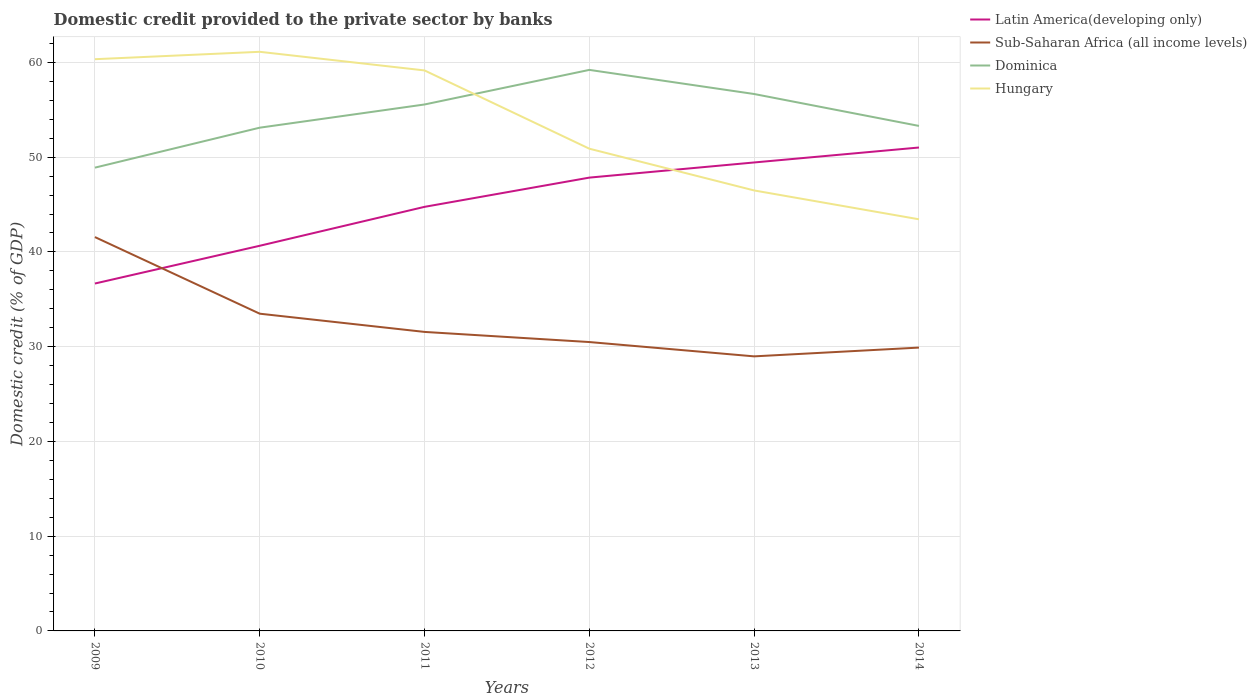Does the line corresponding to Hungary intersect with the line corresponding to Sub-Saharan Africa (all income levels)?
Your answer should be very brief. No. Across all years, what is the maximum domestic credit provided to the private sector by banks in Latin America(developing only)?
Your answer should be very brief. 36.67. In which year was the domestic credit provided to the private sector by banks in Dominica maximum?
Make the answer very short. 2009. What is the total domestic credit provided to the private sector by banks in Dominica in the graph?
Offer a terse response. 5.91. What is the difference between the highest and the second highest domestic credit provided to the private sector by banks in Dominica?
Offer a very short reply. 10.32. Is the domestic credit provided to the private sector by banks in Latin America(developing only) strictly greater than the domestic credit provided to the private sector by banks in Hungary over the years?
Offer a very short reply. No. How many lines are there?
Your answer should be very brief. 4. What is the difference between two consecutive major ticks on the Y-axis?
Provide a succinct answer. 10. Does the graph contain any zero values?
Offer a terse response. No. How many legend labels are there?
Provide a succinct answer. 4. What is the title of the graph?
Provide a short and direct response. Domestic credit provided to the private sector by banks. What is the label or title of the X-axis?
Provide a succinct answer. Years. What is the label or title of the Y-axis?
Ensure brevity in your answer.  Domestic credit (% of GDP). What is the Domestic credit (% of GDP) in Latin America(developing only) in 2009?
Your answer should be very brief. 36.67. What is the Domestic credit (% of GDP) of Sub-Saharan Africa (all income levels) in 2009?
Make the answer very short. 41.57. What is the Domestic credit (% of GDP) in Dominica in 2009?
Ensure brevity in your answer.  48.9. What is the Domestic credit (% of GDP) of Hungary in 2009?
Offer a terse response. 60.34. What is the Domestic credit (% of GDP) in Latin America(developing only) in 2010?
Make the answer very short. 40.65. What is the Domestic credit (% of GDP) in Sub-Saharan Africa (all income levels) in 2010?
Your response must be concise. 33.48. What is the Domestic credit (% of GDP) of Dominica in 2010?
Provide a succinct answer. 53.12. What is the Domestic credit (% of GDP) of Hungary in 2010?
Your response must be concise. 61.12. What is the Domestic credit (% of GDP) in Latin America(developing only) in 2011?
Provide a short and direct response. 44.76. What is the Domestic credit (% of GDP) in Sub-Saharan Africa (all income levels) in 2011?
Make the answer very short. 31.56. What is the Domestic credit (% of GDP) in Dominica in 2011?
Your answer should be very brief. 55.56. What is the Domestic credit (% of GDP) of Hungary in 2011?
Offer a very short reply. 59.16. What is the Domestic credit (% of GDP) of Latin America(developing only) in 2012?
Provide a succinct answer. 47.85. What is the Domestic credit (% of GDP) of Sub-Saharan Africa (all income levels) in 2012?
Provide a short and direct response. 30.49. What is the Domestic credit (% of GDP) of Dominica in 2012?
Provide a succinct answer. 59.21. What is the Domestic credit (% of GDP) of Hungary in 2012?
Make the answer very short. 50.9. What is the Domestic credit (% of GDP) in Latin America(developing only) in 2013?
Ensure brevity in your answer.  49.44. What is the Domestic credit (% of GDP) in Sub-Saharan Africa (all income levels) in 2013?
Ensure brevity in your answer.  28.98. What is the Domestic credit (% of GDP) of Dominica in 2013?
Give a very brief answer. 56.67. What is the Domestic credit (% of GDP) in Hungary in 2013?
Keep it short and to the point. 46.49. What is the Domestic credit (% of GDP) in Latin America(developing only) in 2014?
Provide a succinct answer. 51.02. What is the Domestic credit (% of GDP) in Sub-Saharan Africa (all income levels) in 2014?
Offer a terse response. 29.91. What is the Domestic credit (% of GDP) in Dominica in 2014?
Your answer should be very brief. 53.3. What is the Domestic credit (% of GDP) of Hungary in 2014?
Give a very brief answer. 43.45. Across all years, what is the maximum Domestic credit (% of GDP) of Latin America(developing only)?
Offer a terse response. 51.02. Across all years, what is the maximum Domestic credit (% of GDP) in Sub-Saharan Africa (all income levels)?
Offer a terse response. 41.57. Across all years, what is the maximum Domestic credit (% of GDP) of Dominica?
Your answer should be compact. 59.21. Across all years, what is the maximum Domestic credit (% of GDP) in Hungary?
Provide a succinct answer. 61.12. Across all years, what is the minimum Domestic credit (% of GDP) of Latin America(developing only)?
Make the answer very short. 36.67. Across all years, what is the minimum Domestic credit (% of GDP) in Sub-Saharan Africa (all income levels)?
Provide a succinct answer. 28.98. Across all years, what is the minimum Domestic credit (% of GDP) of Dominica?
Your answer should be compact. 48.9. Across all years, what is the minimum Domestic credit (% of GDP) in Hungary?
Give a very brief answer. 43.45. What is the total Domestic credit (% of GDP) in Latin America(developing only) in the graph?
Provide a succinct answer. 270.39. What is the total Domestic credit (% of GDP) of Sub-Saharan Africa (all income levels) in the graph?
Your answer should be compact. 195.98. What is the total Domestic credit (% of GDP) in Dominica in the graph?
Offer a terse response. 326.76. What is the total Domestic credit (% of GDP) of Hungary in the graph?
Keep it short and to the point. 321.46. What is the difference between the Domestic credit (% of GDP) in Latin America(developing only) in 2009 and that in 2010?
Ensure brevity in your answer.  -3.98. What is the difference between the Domestic credit (% of GDP) in Sub-Saharan Africa (all income levels) in 2009 and that in 2010?
Your answer should be compact. 8.09. What is the difference between the Domestic credit (% of GDP) in Dominica in 2009 and that in 2010?
Provide a short and direct response. -4.22. What is the difference between the Domestic credit (% of GDP) of Hungary in 2009 and that in 2010?
Your answer should be compact. -0.78. What is the difference between the Domestic credit (% of GDP) of Latin America(developing only) in 2009 and that in 2011?
Your answer should be compact. -8.09. What is the difference between the Domestic credit (% of GDP) in Sub-Saharan Africa (all income levels) in 2009 and that in 2011?
Offer a very short reply. 10.01. What is the difference between the Domestic credit (% of GDP) of Dominica in 2009 and that in 2011?
Offer a very short reply. -6.67. What is the difference between the Domestic credit (% of GDP) of Hungary in 2009 and that in 2011?
Provide a short and direct response. 1.19. What is the difference between the Domestic credit (% of GDP) of Latin America(developing only) in 2009 and that in 2012?
Your answer should be very brief. -11.18. What is the difference between the Domestic credit (% of GDP) of Sub-Saharan Africa (all income levels) in 2009 and that in 2012?
Your response must be concise. 11.08. What is the difference between the Domestic credit (% of GDP) in Dominica in 2009 and that in 2012?
Make the answer very short. -10.32. What is the difference between the Domestic credit (% of GDP) in Hungary in 2009 and that in 2012?
Offer a very short reply. 9.45. What is the difference between the Domestic credit (% of GDP) in Latin America(developing only) in 2009 and that in 2013?
Your answer should be very brief. -12.78. What is the difference between the Domestic credit (% of GDP) in Sub-Saharan Africa (all income levels) in 2009 and that in 2013?
Offer a terse response. 12.59. What is the difference between the Domestic credit (% of GDP) of Dominica in 2009 and that in 2013?
Give a very brief answer. -7.77. What is the difference between the Domestic credit (% of GDP) of Hungary in 2009 and that in 2013?
Provide a short and direct response. 13.85. What is the difference between the Domestic credit (% of GDP) in Latin America(developing only) in 2009 and that in 2014?
Provide a short and direct response. -14.36. What is the difference between the Domestic credit (% of GDP) in Sub-Saharan Africa (all income levels) in 2009 and that in 2014?
Offer a very short reply. 11.66. What is the difference between the Domestic credit (% of GDP) in Dominica in 2009 and that in 2014?
Your answer should be very brief. -4.4. What is the difference between the Domestic credit (% of GDP) in Hungary in 2009 and that in 2014?
Your response must be concise. 16.9. What is the difference between the Domestic credit (% of GDP) of Latin America(developing only) in 2010 and that in 2011?
Provide a succinct answer. -4.11. What is the difference between the Domestic credit (% of GDP) in Sub-Saharan Africa (all income levels) in 2010 and that in 2011?
Keep it short and to the point. 1.92. What is the difference between the Domestic credit (% of GDP) in Dominica in 2010 and that in 2011?
Make the answer very short. -2.45. What is the difference between the Domestic credit (% of GDP) in Hungary in 2010 and that in 2011?
Keep it short and to the point. 1.97. What is the difference between the Domestic credit (% of GDP) in Latin America(developing only) in 2010 and that in 2012?
Provide a succinct answer. -7.19. What is the difference between the Domestic credit (% of GDP) in Sub-Saharan Africa (all income levels) in 2010 and that in 2012?
Your response must be concise. 2.99. What is the difference between the Domestic credit (% of GDP) in Dominica in 2010 and that in 2012?
Your answer should be compact. -6.1. What is the difference between the Domestic credit (% of GDP) of Hungary in 2010 and that in 2012?
Provide a short and direct response. 10.23. What is the difference between the Domestic credit (% of GDP) of Latin America(developing only) in 2010 and that in 2013?
Your answer should be very brief. -8.79. What is the difference between the Domestic credit (% of GDP) in Sub-Saharan Africa (all income levels) in 2010 and that in 2013?
Offer a very short reply. 4.5. What is the difference between the Domestic credit (% of GDP) in Dominica in 2010 and that in 2013?
Provide a succinct answer. -3.55. What is the difference between the Domestic credit (% of GDP) of Hungary in 2010 and that in 2013?
Provide a succinct answer. 14.63. What is the difference between the Domestic credit (% of GDP) of Latin America(developing only) in 2010 and that in 2014?
Your response must be concise. -10.37. What is the difference between the Domestic credit (% of GDP) in Sub-Saharan Africa (all income levels) in 2010 and that in 2014?
Make the answer very short. 3.58. What is the difference between the Domestic credit (% of GDP) of Dominica in 2010 and that in 2014?
Give a very brief answer. -0.19. What is the difference between the Domestic credit (% of GDP) in Hungary in 2010 and that in 2014?
Your response must be concise. 17.68. What is the difference between the Domestic credit (% of GDP) in Latin America(developing only) in 2011 and that in 2012?
Keep it short and to the point. -3.09. What is the difference between the Domestic credit (% of GDP) in Sub-Saharan Africa (all income levels) in 2011 and that in 2012?
Make the answer very short. 1.07. What is the difference between the Domestic credit (% of GDP) in Dominica in 2011 and that in 2012?
Offer a terse response. -3.65. What is the difference between the Domestic credit (% of GDP) of Hungary in 2011 and that in 2012?
Keep it short and to the point. 8.26. What is the difference between the Domestic credit (% of GDP) of Latin America(developing only) in 2011 and that in 2013?
Ensure brevity in your answer.  -4.68. What is the difference between the Domestic credit (% of GDP) in Sub-Saharan Africa (all income levels) in 2011 and that in 2013?
Provide a succinct answer. 2.58. What is the difference between the Domestic credit (% of GDP) in Dominica in 2011 and that in 2013?
Give a very brief answer. -1.1. What is the difference between the Domestic credit (% of GDP) in Hungary in 2011 and that in 2013?
Offer a terse response. 12.67. What is the difference between the Domestic credit (% of GDP) of Latin America(developing only) in 2011 and that in 2014?
Your response must be concise. -6.26. What is the difference between the Domestic credit (% of GDP) in Sub-Saharan Africa (all income levels) in 2011 and that in 2014?
Your answer should be very brief. 1.65. What is the difference between the Domestic credit (% of GDP) of Dominica in 2011 and that in 2014?
Offer a terse response. 2.26. What is the difference between the Domestic credit (% of GDP) in Hungary in 2011 and that in 2014?
Your answer should be compact. 15.71. What is the difference between the Domestic credit (% of GDP) of Latin America(developing only) in 2012 and that in 2013?
Provide a succinct answer. -1.6. What is the difference between the Domestic credit (% of GDP) in Sub-Saharan Africa (all income levels) in 2012 and that in 2013?
Your response must be concise. 1.51. What is the difference between the Domestic credit (% of GDP) in Dominica in 2012 and that in 2013?
Provide a short and direct response. 2.55. What is the difference between the Domestic credit (% of GDP) of Hungary in 2012 and that in 2013?
Offer a very short reply. 4.41. What is the difference between the Domestic credit (% of GDP) in Latin America(developing only) in 2012 and that in 2014?
Ensure brevity in your answer.  -3.18. What is the difference between the Domestic credit (% of GDP) in Sub-Saharan Africa (all income levels) in 2012 and that in 2014?
Give a very brief answer. 0.58. What is the difference between the Domestic credit (% of GDP) of Dominica in 2012 and that in 2014?
Ensure brevity in your answer.  5.91. What is the difference between the Domestic credit (% of GDP) of Hungary in 2012 and that in 2014?
Provide a succinct answer. 7.45. What is the difference between the Domestic credit (% of GDP) in Latin America(developing only) in 2013 and that in 2014?
Provide a short and direct response. -1.58. What is the difference between the Domestic credit (% of GDP) of Sub-Saharan Africa (all income levels) in 2013 and that in 2014?
Ensure brevity in your answer.  -0.93. What is the difference between the Domestic credit (% of GDP) in Dominica in 2013 and that in 2014?
Your response must be concise. 3.37. What is the difference between the Domestic credit (% of GDP) in Hungary in 2013 and that in 2014?
Provide a succinct answer. 3.04. What is the difference between the Domestic credit (% of GDP) in Latin America(developing only) in 2009 and the Domestic credit (% of GDP) in Sub-Saharan Africa (all income levels) in 2010?
Provide a succinct answer. 3.18. What is the difference between the Domestic credit (% of GDP) in Latin America(developing only) in 2009 and the Domestic credit (% of GDP) in Dominica in 2010?
Your response must be concise. -16.45. What is the difference between the Domestic credit (% of GDP) in Latin America(developing only) in 2009 and the Domestic credit (% of GDP) in Hungary in 2010?
Offer a terse response. -24.46. What is the difference between the Domestic credit (% of GDP) of Sub-Saharan Africa (all income levels) in 2009 and the Domestic credit (% of GDP) of Dominica in 2010?
Keep it short and to the point. -11.55. What is the difference between the Domestic credit (% of GDP) of Sub-Saharan Africa (all income levels) in 2009 and the Domestic credit (% of GDP) of Hungary in 2010?
Keep it short and to the point. -19.56. What is the difference between the Domestic credit (% of GDP) in Dominica in 2009 and the Domestic credit (% of GDP) in Hungary in 2010?
Make the answer very short. -12.23. What is the difference between the Domestic credit (% of GDP) of Latin America(developing only) in 2009 and the Domestic credit (% of GDP) of Sub-Saharan Africa (all income levels) in 2011?
Your answer should be compact. 5.11. What is the difference between the Domestic credit (% of GDP) in Latin America(developing only) in 2009 and the Domestic credit (% of GDP) in Dominica in 2011?
Make the answer very short. -18.9. What is the difference between the Domestic credit (% of GDP) in Latin America(developing only) in 2009 and the Domestic credit (% of GDP) in Hungary in 2011?
Your answer should be very brief. -22.49. What is the difference between the Domestic credit (% of GDP) of Sub-Saharan Africa (all income levels) in 2009 and the Domestic credit (% of GDP) of Dominica in 2011?
Your answer should be very brief. -14. What is the difference between the Domestic credit (% of GDP) in Sub-Saharan Africa (all income levels) in 2009 and the Domestic credit (% of GDP) in Hungary in 2011?
Provide a succinct answer. -17.59. What is the difference between the Domestic credit (% of GDP) in Dominica in 2009 and the Domestic credit (% of GDP) in Hungary in 2011?
Your answer should be very brief. -10.26. What is the difference between the Domestic credit (% of GDP) of Latin America(developing only) in 2009 and the Domestic credit (% of GDP) of Sub-Saharan Africa (all income levels) in 2012?
Provide a succinct answer. 6.18. What is the difference between the Domestic credit (% of GDP) in Latin America(developing only) in 2009 and the Domestic credit (% of GDP) in Dominica in 2012?
Ensure brevity in your answer.  -22.55. What is the difference between the Domestic credit (% of GDP) of Latin America(developing only) in 2009 and the Domestic credit (% of GDP) of Hungary in 2012?
Give a very brief answer. -14.23. What is the difference between the Domestic credit (% of GDP) in Sub-Saharan Africa (all income levels) in 2009 and the Domestic credit (% of GDP) in Dominica in 2012?
Your answer should be compact. -17.65. What is the difference between the Domestic credit (% of GDP) in Sub-Saharan Africa (all income levels) in 2009 and the Domestic credit (% of GDP) in Hungary in 2012?
Your response must be concise. -9.33. What is the difference between the Domestic credit (% of GDP) of Dominica in 2009 and the Domestic credit (% of GDP) of Hungary in 2012?
Your response must be concise. -2. What is the difference between the Domestic credit (% of GDP) of Latin America(developing only) in 2009 and the Domestic credit (% of GDP) of Sub-Saharan Africa (all income levels) in 2013?
Provide a succinct answer. 7.69. What is the difference between the Domestic credit (% of GDP) in Latin America(developing only) in 2009 and the Domestic credit (% of GDP) in Dominica in 2013?
Give a very brief answer. -20. What is the difference between the Domestic credit (% of GDP) of Latin America(developing only) in 2009 and the Domestic credit (% of GDP) of Hungary in 2013?
Offer a very short reply. -9.82. What is the difference between the Domestic credit (% of GDP) of Sub-Saharan Africa (all income levels) in 2009 and the Domestic credit (% of GDP) of Dominica in 2013?
Keep it short and to the point. -15.1. What is the difference between the Domestic credit (% of GDP) in Sub-Saharan Africa (all income levels) in 2009 and the Domestic credit (% of GDP) in Hungary in 2013?
Provide a short and direct response. -4.92. What is the difference between the Domestic credit (% of GDP) in Dominica in 2009 and the Domestic credit (% of GDP) in Hungary in 2013?
Your answer should be very brief. 2.41. What is the difference between the Domestic credit (% of GDP) of Latin America(developing only) in 2009 and the Domestic credit (% of GDP) of Sub-Saharan Africa (all income levels) in 2014?
Your answer should be compact. 6.76. What is the difference between the Domestic credit (% of GDP) in Latin America(developing only) in 2009 and the Domestic credit (% of GDP) in Dominica in 2014?
Your answer should be compact. -16.64. What is the difference between the Domestic credit (% of GDP) of Latin America(developing only) in 2009 and the Domestic credit (% of GDP) of Hungary in 2014?
Keep it short and to the point. -6.78. What is the difference between the Domestic credit (% of GDP) of Sub-Saharan Africa (all income levels) in 2009 and the Domestic credit (% of GDP) of Dominica in 2014?
Your answer should be very brief. -11.73. What is the difference between the Domestic credit (% of GDP) in Sub-Saharan Africa (all income levels) in 2009 and the Domestic credit (% of GDP) in Hungary in 2014?
Offer a very short reply. -1.88. What is the difference between the Domestic credit (% of GDP) of Dominica in 2009 and the Domestic credit (% of GDP) of Hungary in 2014?
Keep it short and to the point. 5.45. What is the difference between the Domestic credit (% of GDP) in Latin America(developing only) in 2010 and the Domestic credit (% of GDP) in Sub-Saharan Africa (all income levels) in 2011?
Your answer should be compact. 9.09. What is the difference between the Domestic credit (% of GDP) in Latin America(developing only) in 2010 and the Domestic credit (% of GDP) in Dominica in 2011?
Your answer should be very brief. -14.91. What is the difference between the Domestic credit (% of GDP) of Latin America(developing only) in 2010 and the Domestic credit (% of GDP) of Hungary in 2011?
Keep it short and to the point. -18.51. What is the difference between the Domestic credit (% of GDP) in Sub-Saharan Africa (all income levels) in 2010 and the Domestic credit (% of GDP) in Dominica in 2011?
Ensure brevity in your answer.  -22.08. What is the difference between the Domestic credit (% of GDP) in Sub-Saharan Africa (all income levels) in 2010 and the Domestic credit (% of GDP) in Hungary in 2011?
Offer a terse response. -25.68. What is the difference between the Domestic credit (% of GDP) of Dominica in 2010 and the Domestic credit (% of GDP) of Hungary in 2011?
Give a very brief answer. -6.04. What is the difference between the Domestic credit (% of GDP) in Latin America(developing only) in 2010 and the Domestic credit (% of GDP) in Sub-Saharan Africa (all income levels) in 2012?
Offer a very short reply. 10.16. What is the difference between the Domestic credit (% of GDP) in Latin America(developing only) in 2010 and the Domestic credit (% of GDP) in Dominica in 2012?
Your response must be concise. -18.56. What is the difference between the Domestic credit (% of GDP) of Latin America(developing only) in 2010 and the Domestic credit (% of GDP) of Hungary in 2012?
Your answer should be very brief. -10.25. What is the difference between the Domestic credit (% of GDP) in Sub-Saharan Africa (all income levels) in 2010 and the Domestic credit (% of GDP) in Dominica in 2012?
Offer a terse response. -25.73. What is the difference between the Domestic credit (% of GDP) in Sub-Saharan Africa (all income levels) in 2010 and the Domestic credit (% of GDP) in Hungary in 2012?
Your answer should be very brief. -17.41. What is the difference between the Domestic credit (% of GDP) of Dominica in 2010 and the Domestic credit (% of GDP) of Hungary in 2012?
Your response must be concise. 2.22. What is the difference between the Domestic credit (% of GDP) in Latin America(developing only) in 2010 and the Domestic credit (% of GDP) in Sub-Saharan Africa (all income levels) in 2013?
Provide a short and direct response. 11.67. What is the difference between the Domestic credit (% of GDP) in Latin America(developing only) in 2010 and the Domestic credit (% of GDP) in Dominica in 2013?
Give a very brief answer. -16.02. What is the difference between the Domestic credit (% of GDP) in Latin America(developing only) in 2010 and the Domestic credit (% of GDP) in Hungary in 2013?
Your response must be concise. -5.84. What is the difference between the Domestic credit (% of GDP) of Sub-Saharan Africa (all income levels) in 2010 and the Domestic credit (% of GDP) of Dominica in 2013?
Give a very brief answer. -23.19. What is the difference between the Domestic credit (% of GDP) of Sub-Saharan Africa (all income levels) in 2010 and the Domestic credit (% of GDP) of Hungary in 2013?
Make the answer very short. -13.01. What is the difference between the Domestic credit (% of GDP) in Dominica in 2010 and the Domestic credit (% of GDP) in Hungary in 2013?
Give a very brief answer. 6.63. What is the difference between the Domestic credit (% of GDP) of Latin America(developing only) in 2010 and the Domestic credit (% of GDP) of Sub-Saharan Africa (all income levels) in 2014?
Ensure brevity in your answer.  10.75. What is the difference between the Domestic credit (% of GDP) in Latin America(developing only) in 2010 and the Domestic credit (% of GDP) in Dominica in 2014?
Ensure brevity in your answer.  -12.65. What is the difference between the Domestic credit (% of GDP) of Latin America(developing only) in 2010 and the Domestic credit (% of GDP) of Hungary in 2014?
Your response must be concise. -2.8. What is the difference between the Domestic credit (% of GDP) of Sub-Saharan Africa (all income levels) in 2010 and the Domestic credit (% of GDP) of Dominica in 2014?
Ensure brevity in your answer.  -19.82. What is the difference between the Domestic credit (% of GDP) of Sub-Saharan Africa (all income levels) in 2010 and the Domestic credit (% of GDP) of Hungary in 2014?
Provide a short and direct response. -9.96. What is the difference between the Domestic credit (% of GDP) in Dominica in 2010 and the Domestic credit (% of GDP) in Hungary in 2014?
Provide a succinct answer. 9.67. What is the difference between the Domestic credit (% of GDP) in Latin America(developing only) in 2011 and the Domestic credit (% of GDP) in Sub-Saharan Africa (all income levels) in 2012?
Make the answer very short. 14.27. What is the difference between the Domestic credit (% of GDP) of Latin America(developing only) in 2011 and the Domestic credit (% of GDP) of Dominica in 2012?
Provide a short and direct response. -14.46. What is the difference between the Domestic credit (% of GDP) of Latin America(developing only) in 2011 and the Domestic credit (% of GDP) of Hungary in 2012?
Offer a very short reply. -6.14. What is the difference between the Domestic credit (% of GDP) in Sub-Saharan Africa (all income levels) in 2011 and the Domestic credit (% of GDP) in Dominica in 2012?
Keep it short and to the point. -27.66. What is the difference between the Domestic credit (% of GDP) of Sub-Saharan Africa (all income levels) in 2011 and the Domestic credit (% of GDP) of Hungary in 2012?
Keep it short and to the point. -19.34. What is the difference between the Domestic credit (% of GDP) of Dominica in 2011 and the Domestic credit (% of GDP) of Hungary in 2012?
Ensure brevity in your answer.  4.67. What is the difference between the Domestic credit (% of GDP) in Latin America(developing only) in 2011 and the Domestic credit (% of GDP) in Sub-Saharan Africa (all income levels) in 2013?
Provide a succinct answer. 15.78. What is the difference between the Domestic credit (% of GDP) in Latin America(developing only) in 2011 and the Domestic credit (% of GDP) in Dominica in 2013?
Keep it short and to the point. -11.91. What is the difference between the Domestic credit (% of GDP) in Latin America(developing only) in 2011 and the Domestic credit (% of GDP) in Hungary in 2013?
Give a very brief answer. -1.73. What is the difference between the Domestic credit (% of GDP) of Sub-Saharan Africa (all income levels) in 2011 and the Domestic credit (% of GDP) of Dominica in 2013?
Your answer should be compact. -25.11. What is the difference between the Domestic credit (% of GDP) in Sub-Saharan Africa (all income levels) in 2011 and the Domestic credit (% of GDP) in Hungary in 2013?
Offer a very short reply. -14.93. What is the difference between the Domestic credit (% of GDP) of Dominica in 2011 and the Domestic credit (% of GDP) of Hungary in 2013?
Your response must be concise. 9.07. What is the difference between the Domestic credit (% of GDP) in Latin America(developing only) in 2011 and the Domestic credit (% of GDP) in Sub-Saharan Africa (all income levels) in 2014?
Your answer should be compact. 14.85. What is the difference between the Domestic credit (% of GDP) of Latin America(developing only) in 2011 and the Domestic credit (% of GDP) of Dominica in 2014?
Offer a terse response. -8.54. What is the difference between the Domestic credit (% of GDP) of Latin America(developing only) in 2011 and the Domestic credit (% of GDP) of Hungary in 2014?
Provide a short and direct response. 1.31. What is the difference between the Domestic credit (% of GDP) in Sub-Saharan Africa (all income levels) in 2011 and the Domestic credit (% of GDP) in Dominica in 2014?
Your answer should be compact. -21.74. What is the difference between the Domestic credit (% of GDP) in Sub-Saharan Africa (all income levels) in 2011 and the Domestic credit (% of GDP) in Hungary in 2014?
Give a very brief answer. -11.89. What is the difference between the Domestic credit (% of GDP) in Dominica in 2011 and the Domestic credit (% of GDP) in Hungary in 2014?
Your answer should be compact. 12.12. What is the difference between the Domestic credit (% of GDP) of Latin America(developing only) in 2012 and the Domestic credit (% of GDP) of Sub-Saharan Africa (all income levels) in 2013?
Give a very brief answer. 18.87. What is the difference between the Domestic credit (% of GDP) of Latin America(developing only) in 2012 and the Domestic credit (% of GDP) of Dominica in 2013?
Keep it short and to the point. -8.82. What is the difference between the Domestic credit (% of GDP) in Latin America(developing only) in 2012 and the Domestic credit (% of GDP) in Hungary in 2013?
Ensure brevity in your answer.  1.35. What is the difference between the Domestic credit (% of GDP) in Sub-Saharan Africa (all income levels) in 2012 and the Domestic credit (% of GDP) in Dominica in 2013?
Your answer should be very brief. -26.18. What is the difference between the Domestic credit (% of GDP) in Sub-Saharan Africa (all income levels) in 2012 and the Domestic credit (% of GDP) in Hungary in 2013?
Your answer should be very brief. -16. What is the difference between the Domestic credit (% of GDP) of Dominica in 2012 and the Domestic credit (% of GDP) of Hungary in 2013?
Ensure brevity in your answer.  12.72. What is the difference between the Domestic credit (% of GDP) of Latin America(developing only) in 2012 and the Domestic credit (% of GDP) of Sub-Saharan Africa (all income levels) in 2014?
Give a very brief answer. 17.94. What is the difference between the Domestic credit (% of GDP) in Latin America(developing only) in 2012 and the Domestic credit (% of GDP) in Dominica in 2014?
Offer a terse response. -5.46. What is the difference between the Domestic credit (% of GDP) of Latin America(developing only) in 2012 and the Domestic credit (% of GDP) of Hungary in 2014?
Ensure brevity in your answer.  4.4. What is the difference between the Domestic credit (% of GDP) in Sub-Saharan Africa (all income levels) in 2012 and the Domestic credit (% of GDP) in Dominica in 2014?
Make the answer very short. -22.81. What is the difference between the Domestic credit (% of GDP) of Sub-Saharan Africa (all income levels) in 2012 and the Domestic credit (% of GDP) of Hungary in 2014?
Offer a very short reply. -12.96. What is the difference between the Domestic credit (% of GDP) in Dominica in 2012 and the Domestic credit (% of GDP) in Hungary in 2014?
Your response must be concise. 15.77. What is the difference between the Domestic credit (% of GDP) of Latin America(developing only) in 2013 and the Domestic credit (% of GDP) of Sub-Saharan Africa (all income levels) in 2014?
Your response must be concise. 19.54. What is the difference between the Domestic credit (% of GDP) of Latin America(developing only) in 2013 and the Domestic credit (% of GDP) of Dominica in 2014?
Offer a very short reply. -3.86. What is the difference between the Domestic credit (% of GDP) in Latin America(developing only) in 2013 and the Domestic credit (% of GDP) in Hungary in 2014?
Keep it short and to the point. 6. What is the difference between the Domestic credit (% of GDP) of Sub-Saharan Africa (all income levels) in 2013 and the Domestic credit (% of GDP) of Dominica in 2014?
Ensure brevity in your answer.  -24.32. What is the difference between the Domestic credit (% of GDP) of Sub-Saharan Africa (all income levels) in 2013 and the Domestic credit (% of GDP) of Hungary in 2014?
Provide a short and direct response. -14.47. What is the difference between the Domestic credit (% of GDP) of Dominica in 2013 and the Domestic credit (% of GDP) of Hungary in 2014?
Offer a terse response. 13.22. What is the average Domestic credit (% of GDP) of Latin America(developing only) per year?
Your answer should be compact. 45.06. What is the average Domestic credit (% of GDP) in Sub-Saharan Africa (all income levels) per year?
Keep it short and to the point. 32.66. What is the average Domestic credit (% of GDP) in Dominica per year?
Keep it short and to the point. 54.46. What is the average Domestic credit (% of GDP) of Hungary per year?
Ensure brevity in your answer.  53.58. In the year 2009, what is the difference between the Domestic credit (% of GDP) of Latin America(developing only) and Domestic credit (% of GDP) of Sub-Saharan Africa (all income levels)?
Your answer should be compact. -4.9. In the year 2009, what is the difference between the Domestic credit (% of GDP) of Latin America(developing only) and Domestic credit (% of GDP) of Dominica?
Provide a succinct answer. -12.23. In the year 2009, what is the difference between the Domestic credit (% of GDP) of Latin America(developing only) and Domestic credit (% of GDP) of Hungary?
Keep it short and to the point. -23.68. In the year 2009, what is the difference between the Domestic credit (% of GDP) in Sub-Saharan Africa (all income levels) and Domestic credit (% of GDP) in Dominica?
Make the answer very short. -7.33. In the year 2009, what is the difference between the Domestic credit (% of GDP) of Sub-Saharan Africa (all income levels) and Domestic credit (% of GDP) of Hungary?
Make the answer very short. -18.78. In the year 2009, what is the difference between the Domestic credit (% of GDP) in Dominica and Domestic credit (% of GDP) in Hungary?
Your answer should be very brief. -11.45. In the year 2010, what is the difference between the Domestic credit (% of GDP) in Latin America(developing only) and Domestic credit (% of GDP) in Sub-Saharan Africa (all income levels)?
Ensure brevity in your answer.  7.17. In the year 2010, what is the difference between the Domestic credit (% of GDP) in Latin America(developing only) and Domestic credit (% of GDP) in Dominica?
Keep it short and to the point. -12.47. In the year 2010, what is the difference between the Domestic credit (% of GDP) of Latin America(developing only) and Domestic credit (% of GDP) of Hungary?
Your answer should be very brief. -20.47. In the year 2010, what is the difference between the Domestic credit (% of GDP) of Sub-Saharan Africa (all income levels) and Domestic credit (% of GDP) of Dominica?
Provide a succinct answer. -19.63. In the year 2010, what is the difference between the Domestic credit (% of GDP) in Sub-Saharan Africa (all income levels) and Domestic credit (% of GDP) in Hungary?
Make the answer very short. -27.64. In the year 2010, what is the difference between the Domestic credit (% of GDP) in Dominica and Domestic credit (% of GDP) in Hungary?
Your answer should be compact. -8.01. In the year 2011, what is the difference between the Domestic credit (% of GDP) of Latin America(developing only) and Domestic credit (% of GDP) of Sub-Saharan Africa (all income levels)?
Give a very brief answer. 13.2. In the year 2011, what is the difference between the Domestic credit (% of GDP) in Latin America(developing only) and Domestic credit (% of GDP) in Dominica?
Ensure brevity in your answer.  -10.8. In the year 2011, what is the difference between the Domestic credit (% of GDP) in Latin America(developing only) and Domestic credit (% of GDP) in Hungary?
Offer a very short reply. -14.4. In the year 2011, what is the difference between the Domestic credit (% of GDP) of Sub-Saharan Africa (all income levels) and Domestic credit (% of GDP) of Dominica?
Provide a succinct answer. -24.01. In the year 2011, what is the difference between the Domestic credit (% of GDP) in Sub-Saharan Africa (all income levels) and Domestic credit (% of GDP) in Hungary?
Your answer should be very brief. -27.6. In the year 2011, what is the difference between the Domestic credit (% of GDP) in Dominica and Domestic credit (% of GDP) in Hungary?
Your answer should be compact. -3.59. In the year 2012, what is the difference between the Domestic credit (% of GDP) in Latin America(developing only) and Domestic credit (% of GDP) in Sub-Saharan Africa (all income levels)?
Your answer should be very brief. 17.36. In the year 2012, what is the difference between the Domestic credit (% of GDP) of Latin America(developing only) and Domestic credit (% of GDP) of Dominica?
Your answer should be very brief. -11.37. In the year 2012, what is the difference between the Domestic credit (% of GDP) of Latin America(developing only) and Domestic credit (% of GDP) of Hungary?
Ensure brevity in your answer.  -3.05. In the year 2012, what is the difference between the Domestic credit (% of GDP) in Sub-Saharan Africa (all income levels) and Domestic credit (% of GDP) in Dominica?
Ensure brevity in your answer.  -28.73. In the year 2012, what is the difference between the Domestic credit (% of GDP) of Sub-Saharan Africa (all income levels) and Domestic credit (% of GDP) of Hungary?
Your answer should be very brief. -20.41. In the year 2012, what is the difference between the Domestic credit (% of GDP) of Dominica and Domestic credit (% of GDP) of Hungary?
Keep it short and to the point. 8.32. In the year 2013, what is the difference between the Domestic credit (% of GDP) in Latin America(developing only) and Domestic credit (% of GDP) in Sub-Saharan Africa (all income levels)?
Offer a terse response. 20.47. In the year 2013, what is the difference between the Domestic credit (% of GDP) in Latin America(developing only) and Domestic credit (% of GDP) in Dominica?
Your response must be concise. -7.22. In the year 2013, what is the difference between the Domestic credit (% of GDP) of Latin America(developing only) and Domestic credit (% of GDP) of Hungary?
Offer a terse response. 2.95. In the year 2013, what is the difference between the Domestic credit (% of GDP) of Sub-Saharan Africa (all income levels) and Domestic credit (% of GDP) of Dominica?
Your answer should be compact. -27.69. In the year 2013, what is the difference between the Domestic credit (% of GDP) in Sub-Saharan Africa (all income levels) and Domestic credit (% of GDP) in Hungary?
Make the answer very short. -17.51. In the year 2013, what is the difference between the Domestic credit (% of GDP) of Dominica and Domestic credit (% of GDP) of Hungary?
Ensure brevity in your answer.  10.18. In the year 2014, what is the difference between the Domestic credit (% of GDP) in Latin America(developing only) and Domestic credit (% of GDP) in Sub-Saharan Africa (all income levels)?
Keep it short and to the point. 21.12. In the year 2014, what is the difference between the Domestic credit (% of GDP) of Latin America(developing only) and Domestic credit (% of GDP) of Dominica?
Your answer should be very brief. -2.28. In the year 2014, what is the difference between the Domestic credit (% of GDP) in Latin America(developing only) and Domestic credit (% of GDP) in Hungary?
Offer a very short reply. 7.58. In the year 2014, what is the difference between the Domestic credit (% of GDP) of Sub-Saharan Africa (all income levels) and Domestic credit (% of GDP) of Dominica?
Provide a succinct answer. -23.4. In the year 2014, what is the difference between the Domestic credit (% of GDP) of Sub-Saharan Africa (all income levels) and Domestic credit (% of GDP) of Hungary?
Offer a terse response. -13.54. In the year 2014, what is the difference between the Domestic credit (% of GDP) in Dominica and Domestic credit (% of GDP) in Hungary?
Your response must be concise. 9.86. What is the ratio of the Domestic credit (% of GDP) of Latin America(developing only) in 2009 to that in 2010?
Your response must be concise. 0.9. What is the ratio of the Domestic credit (% of GDP) in Sub-Saharan Africa (all income levels) in 2009 to that in 2010?
Keep it short and to the point. 1.24. What is the ratio of the Domestic credit (% of GDP) of Dominica in 2009 to that in 2010?
Keep it short and to the point. 0.92. What is the ratio of the Domestic credit (% of GDP) of Hungary in 2009 to that in 2010?
Provide a succinct answer. 0.99. What is the ratio of the Domestic credit (% of GDP) in Latin America(developing only) in 2009 to that in 2011?
Keep it short and to the point. 0.82. What is the ratio of the Domestic credit (% of GDP) in Sub-Saharan Africa (all income levels) in 2009 to that in 2011?
Keep it short and to the point. 1.32. What is the ratio of the Domestic credit (% of GDP) of Hungary in 2009 to that in 2011?
Your answer should be very brief. 1.02. What is the ratio of the Domestic credit (% of GDP) in Latin America(developing only) in 2009 to that in 2012?
Offer a very short reply. 0.77. What is the ratio of the Domestic credit (% of GDP) of Sub-Saharan Africa (all income levels) in 2009 to that in 2012?
Provide a succinct answer. 1.36. What is the ratio of the Domestic credit (% of GDP) in Dominica in 2009 to that in 2012?
Ensure brevity in your answer.  0.83. What is the ratio of the Domestic credit (% of GDP) in Hungary in 2009 to that in 2012?
Make the answer very short. 1.19. What is the ratio of the Domestic credit (% of GDP) in Latin America(developing only) in 2009 to that in 2013?
Give a very brief answer. 0.74. What is the ratio of the Domestic credit (% of GDP) of Sub-Saharan Africa (all income levels) in 2009 to that in 2013?
Give a very brief answer. 1.43. What is the ratio of the Domestic credit (% of GDP) of Dominica in 2009 to that in 2013?
Provide a succinct answer. 0.86. What is the ratio of the Domestic credit (% of GDP) of Hungary in 2009 to that in 2013?
Make the answer very short. 1.3. What is the ratio of the Domestic credit (% of GDP) of Latin America(developing only) in 2009 to that in 2014?
Make the answer very short. 0.72. What is the ratio of the Domestic credit (% of GDP) of Sub-Saharan Africa (all income levels) in 2009 to that in 2014?
Your answer should be very brief. 1.39. What is the ratio of the Domestic credit (% of GDP) of Dominica in 2009 to that in 2014?
Provide a succinct answer. 0.92. What is the ratio of the Domestic credit (% of GDP) in Hungary in 2009 to that in 2014?
Give a very brief answer. 1.39. What is the ratio of the Domestic credit (% of GDP) of Latin America(developing only) in 2010 to that in 2011?
Ensure brevity in your answer.  0.91. What is the ratio of the Domestic credit (% of GDP) of Sub-Saharan Africa (all income levels) in 2010 to that in 2011?
Provide a short and direct response. 1.06. What is the ratio of the Domestic credit (% of GDP) of Dominica in 2010 to that in 2011?
Make the answer very short. 0.96. What is the ratio of the Domestic credit (% of GDP) of Hungary in 2010 to that in 2011?
Make the answer very short. 1.03. What is the ratio of the Domestic credit (% of GDP) of Latin America(developing only) in 2010 to that in 2012?
Make the answer very short. 0.85. What is the ratio of the Domestic credit (% of GDP) of Sub-Saharan Africa (all income levels) in 2010 to that in 2012?
Offer a terse response. 1.1. What is the ratio of the Domestic credit (% of GDP) in Dominica in 2010 to that in 2012?
Provide a succinct answer. 0.9. What is the ratio of the Domestic credit (% of GDP) in Hungary in 2010 to that in 2012?
Provide a short and direct response. 1.2. What is the ratio of the Domestic credit (% of GDP) in Latin America(developing only) in 2010 to that in 2013?
Keep it short and to the point. 0.82. What is the ratio of the Domestic credit (% of GDP) of Sub-Saharan Africa (all income levels) in 2010 to that in 2013?
Offer a very short reply. 1.16. What is the ratio of the Domestic credit (% of GDP) of Dominica in 2010 to that in 2013?
Your answer should be compact. 0.94. What is the ratio of the Domestic credit (% of GDP) of Hungary in 2010 to that in 2013?
Offer a terse response. 1.31. What is the ratio of the Domestic credit (% of GDP) in Latin America(developing only) in 2010 to that in 2014?
Offer a very short reply. 0.8. What is the ratio of the Domestic credit (% of GDP) of Sub-Saharan Africa (all income levels) in 2010 to that in 2014?
Your answer should be compact. 1.12. What is the ratio of the Domestic credit (% of GDP) of Hungary in 2010 to that in 2014?
Your answer should be compact. 1.41. What is the ratio of the Domestic credit (% of GDP) of Latin America(developing only) in 2011 to that in 2012?
Provide a succinct answer. 0.94. What is the ratio of the Domestic credit (% of GDP) of Sub-Saharan Africa (all income levels) in 2011 to that in 2012?
Offer a terse response. 1.04. What is the ratio of the Domestic credit (% of GDP) of Dominica in 2011 to that in 2012?
Ensure brevity in your answer.  0.94. What is the ratio of the Domestic credit (% of GDP) in Hungary in 2011 to that in 2012?
Offer a terse response. 1.16. What is the ratio of the Domestic credit (% of GDP) in Latin America(developing only) in 2011 to that in 2013?
Offer a very short reply. 0.91. What is the ratio of the Domestic credit (% of GDP) of Sub-Saharan Africa (all income levels) in 2011 to that in 2013?
Provide a succinct answer. 1.09. What is the ratio of the Domestic credit (% of GDP) in Dominica in 2011 to that in 2013?
Your answer should be very brief. 0.98. What is the ratio of the Domestic credit (% of GDP) in Hungary in 2011 to that in 2013?
Your answer should be very brief. 1.27. What is the ratio of the Domestic credit (% of GDP) in Latin America(developing only) in 2011 to that in 2014?
Keep it short and to the point. 0.88. What is the ratio of the Domestic credit (% of GDP) in Sub-Saharan Africa (all income levels) in 2011 to that in 2014?
Offer a terse response. 1.06. What is the ratio of the Domestic credit (% of GDP) of Dominica in 2011 to that in 2014?
Your answer should be compact. 1.04. What is the ratio of the Domestic credit (% of GDP) in Hungary in 2011 to that in 2014?
Provide a short and direct response. 1.36. What is the ratio of the Domestic credit (% of GDP) in Sub-Saharan Africa (all income levels) in 2012 to that in 2013?
Provide a short and direct response. 1.05. What is the ratio of the Domestic credit (% of GDP) in Dominica in 2012 to that in 2013?
Your answer should be compact. 1.04. What is the ratio of the Domestic credit (% of GDP) of Hungary in 2012 to that in 2013?
Make the answer very short. 1.09. What is the ratio of the Domestic credit (% of GDP) in Latin America(developing only) in 2012 to that in 2014?
Offer a terse response. 0.94. What is the ratio of the Domestic credit (% of GDP) in Sub-Saharan Africa (all income levels) in 2012 to that in 2014?
Keep it short and to the point. 1.02. What is the ratio of the Domestic credit (% of GDP) of Dominica in 2012 to that in 2014?
Your answer should be very brief. 1.11. What is the ratio of the Domestic credit (% of GDP) in Hungary in 2012 to that in 2014?
Make the answer very short. 1.17. What is the ratio of the Domestic credit (% of GDP) of Latin America(developing only) in 2013 to that in 2014?
Your answer should be very brief. 0.97. What is the ratio of the Domestic credit (% of GDP) in Sub-Saharan Africa (all income levels) in 2013 to that in 2014?
Provide a succinct answer. 0.97. What is the ratio of the Domestic credit (% of GDP) of Dominica in 2013 to that in 2014?
Your answer should be very brief. 1.06. What is the ratio of the Domestic credit (% of GDP) in Hungary in 2013 to that in 2014?
Make the answer very short. 1.07. What is the difference between the highest and the second highest Domestic credit (% of GDP) of Latin America(developing only)?
Your answer should be compact. 1.58. What is the difference between the highest and the second highest Domestic credit (% of GDP) of Sub-Saharan Africa (all income levels)?
Offer a very short reply. 8.09. What is the difference between the highest and the second highest Domestic credit (% of GDP) in Dominica?
Offer a terse response. 2.55. What is the difference between the highest and the second highest Domestic credit (% of GDP) in Hungary?
Ensure brevity in your answer.  0.78. What is the difference between the highest and the lowest Domestic credit (% of GDP) in Latin America(developing only)?
Offer a very short reply. 14.36. What is the difference between the highest and the lowest Domestic credit (% of GDP) of Sub-Saharan Africa (all income levels)?
Ensure brevity in your answer.  12.59. What is the difference between the highest and the lowest Domestic credit (% of GDP) in Dominica?
Make the answer very short. 10.32. What is the difference between the highest and the lowest Domestic credit (% of GDP) in Hungary?
Provide a short and direct response. 17.68. 